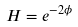<formula> <loc_0><loc_0><loc_500><loc_500>H = e ^ { - 2 \phi }</formula> 